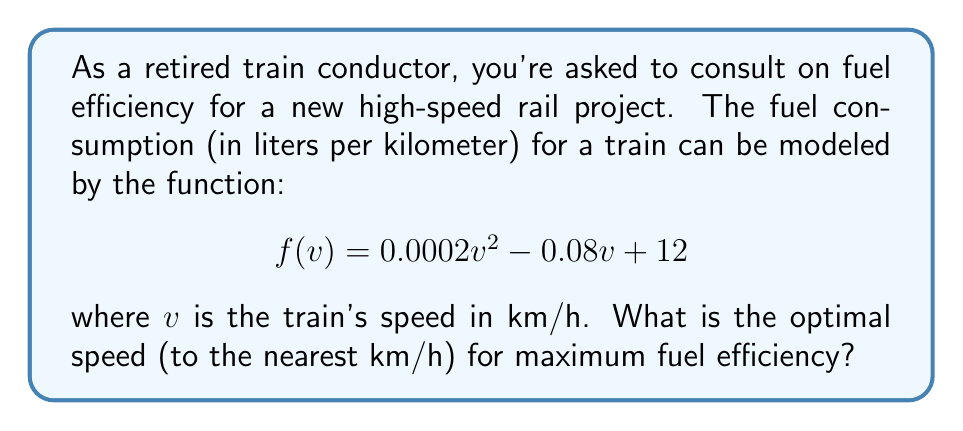Show me your answer to this math problem. To find the optimal speed for maximum fuel efficiency, we need to find the minimum point of the fuel consumption function. This occurs where the derivative of the function is zero.

1. First, let's find the derivative of $f(v)$:
   $$f'(v) = 0.0004v - 0.08$$

2. Set the derivative to zero and solve for $v$:
   $$0.0004v - 0.08 = 0$$
   $$0.0004v = 0.08$$
   $$v = \frac{0.08}{0.0004} = 200$$

3. To confirm this is a minimum (not a maximum), we can check the second derivative:
   $$f''(v) = 0.0004$$
   Since $f''(v)$ is positive, this confirms we have found a minimum.

4. Therefore, the optimal speed for maximum fuel efficiency is 200 km/h.

5. The question asks for the answer to the nearest km/h, so no rounding is necessary.
Answer: 200 km/h 